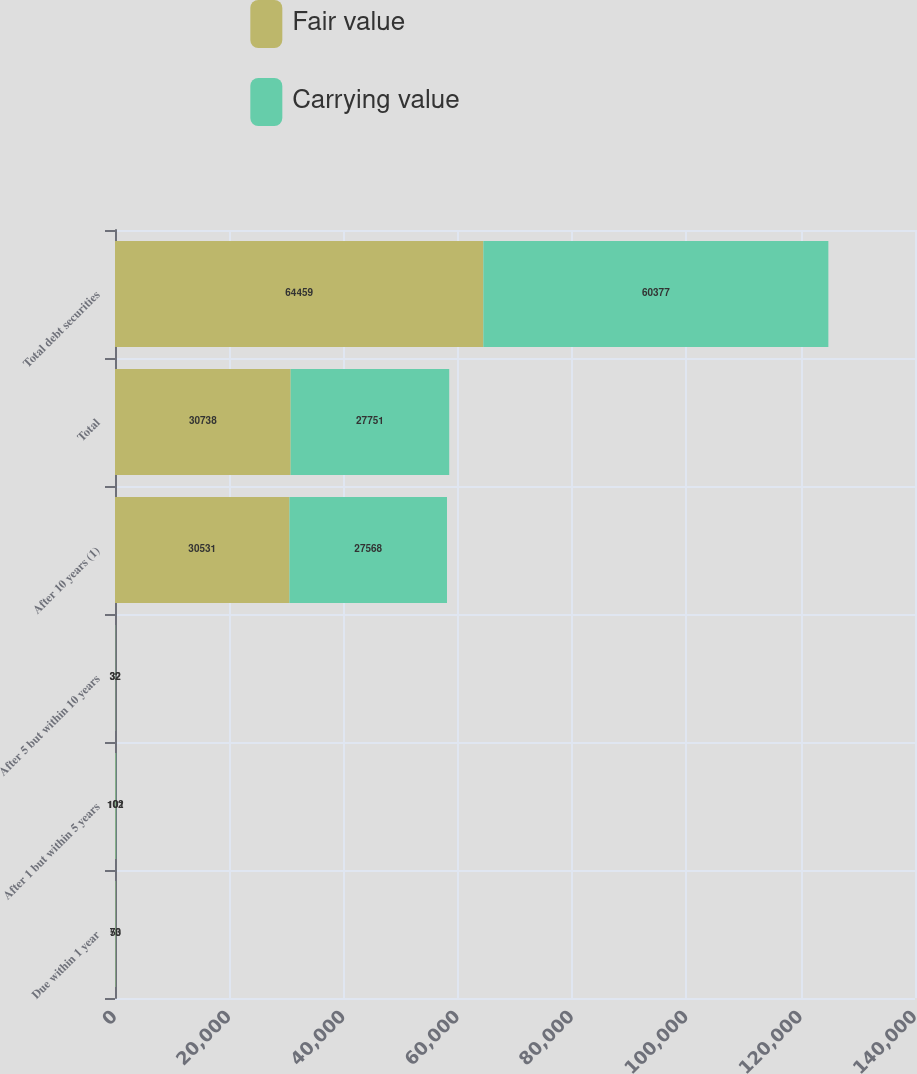<chart> <loc_0><loc_0><loc_500><loc_500><stacked_bar_chart><ecel><fcel>Due within 1 year<fcel>After 1 but within 5 years<fcel>After 5 but within 10 years<fcel>After 10 years (1)<fcel>Total<fcel>Total debt securities<nl><fcel>Fair value<fcel>73<fcel>102<fcel>32<fcel>30531<fcel>30738<fcel>64459<nl><fcel>Carrying value<fcel>50<fcel>101<fcel>32<fcel>27568<fcel>27751<fcel>60377<nl></chart> 